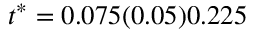<formula> <loc_0><loc_0><loc_500><loc_500>t ^ { * } = 0 . 0 7 5 ( 0 . 0 5 ) 0 . 2 2 5</formula> 